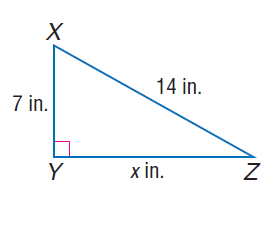Question: Find x.
Choices:
A. 7
B. 7 \sqrt { 3 }
C. 14
D. 7 \sqrt { 5 }
Answer with the letter. Answer: B 